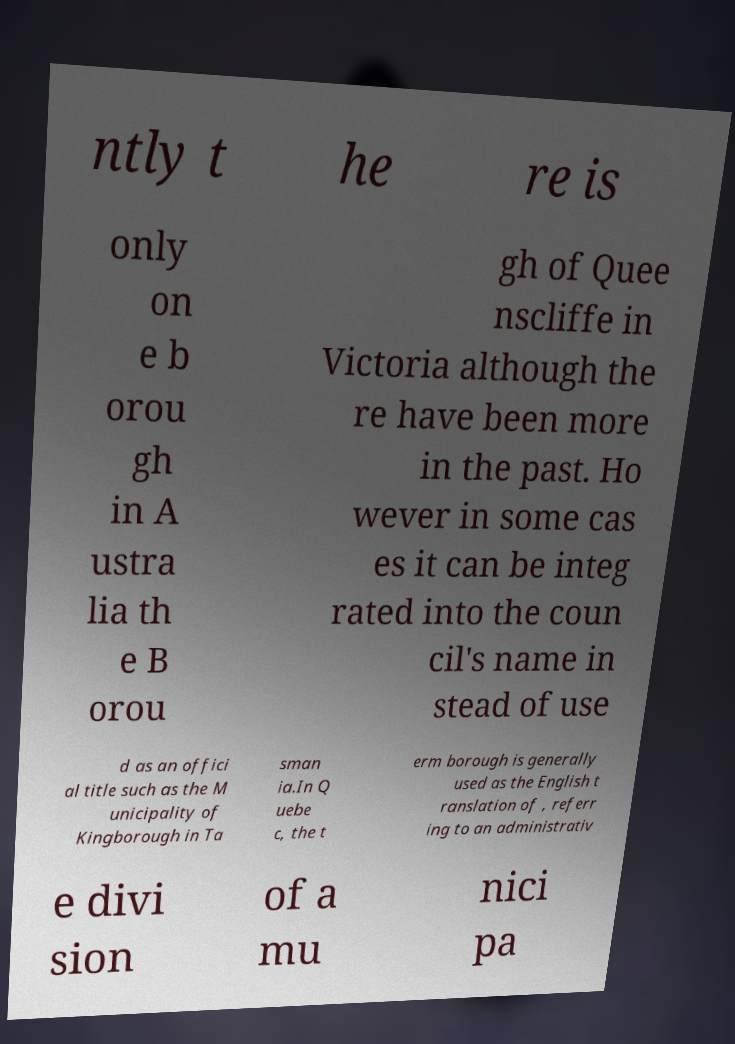For documentation purposes, I need the text within this image transcribed. Could you provide that? ntly t he re is only on e b orou gh in A ustra lia th e B orou gh of Quee nscliffe in Victoria although the re have been more in the past. Ho wever in some cas es it can be integ rated into the coun cil's name in stead of use d as an offici al title such as the M unicipality of Kingborough in Ta sman ia.In Q uebe c, the t erm borough is generally used as the English t ranslation of , referr ing to an administrativ e divi sion of a mu nici pa 